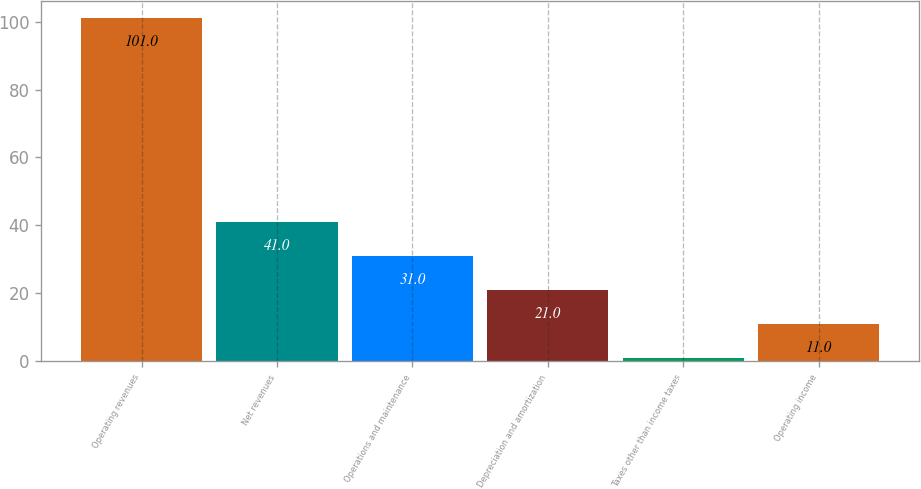Convert chart. <chart><loc_0><loc_0><loc_500><loc_500><bar_chart><fcel>Operating revenues<fcel>Net revenues<fcel>Operations and maintenance<fcel>Depreciation and amortization<fcel>Taxes other than income taxes<fcel>Operating income<nl><fcel>101<fcel>41<fcel>31<fcel>21<fcel>1<fcel>11<nl></chart> 